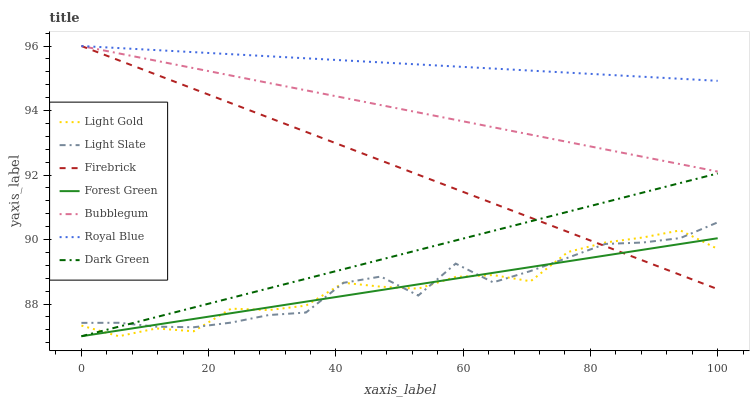Does Firebrick have the minimum area under the curve?
Answer yes or no. No. Does Firebrick have the maximum area under the curve?
Answer yes or no. No. Is Firebrick the smoothest?
Answer yes or no. No. Is Firebrick the roughest?
Answer yes or no. No. Does Firebrick have the lowest value?
Answer yes or no. No. Does Forest Green have the highest value?
Answer yes or no. No. Is Forest Green less than Royal Blue?
Answer yes or no. Yes. Is Bubblegum greater than Light Slate?
Answer yes or no. Yes. Does Forest Green intersect Royal Blue?
Answer yes or no. No. 